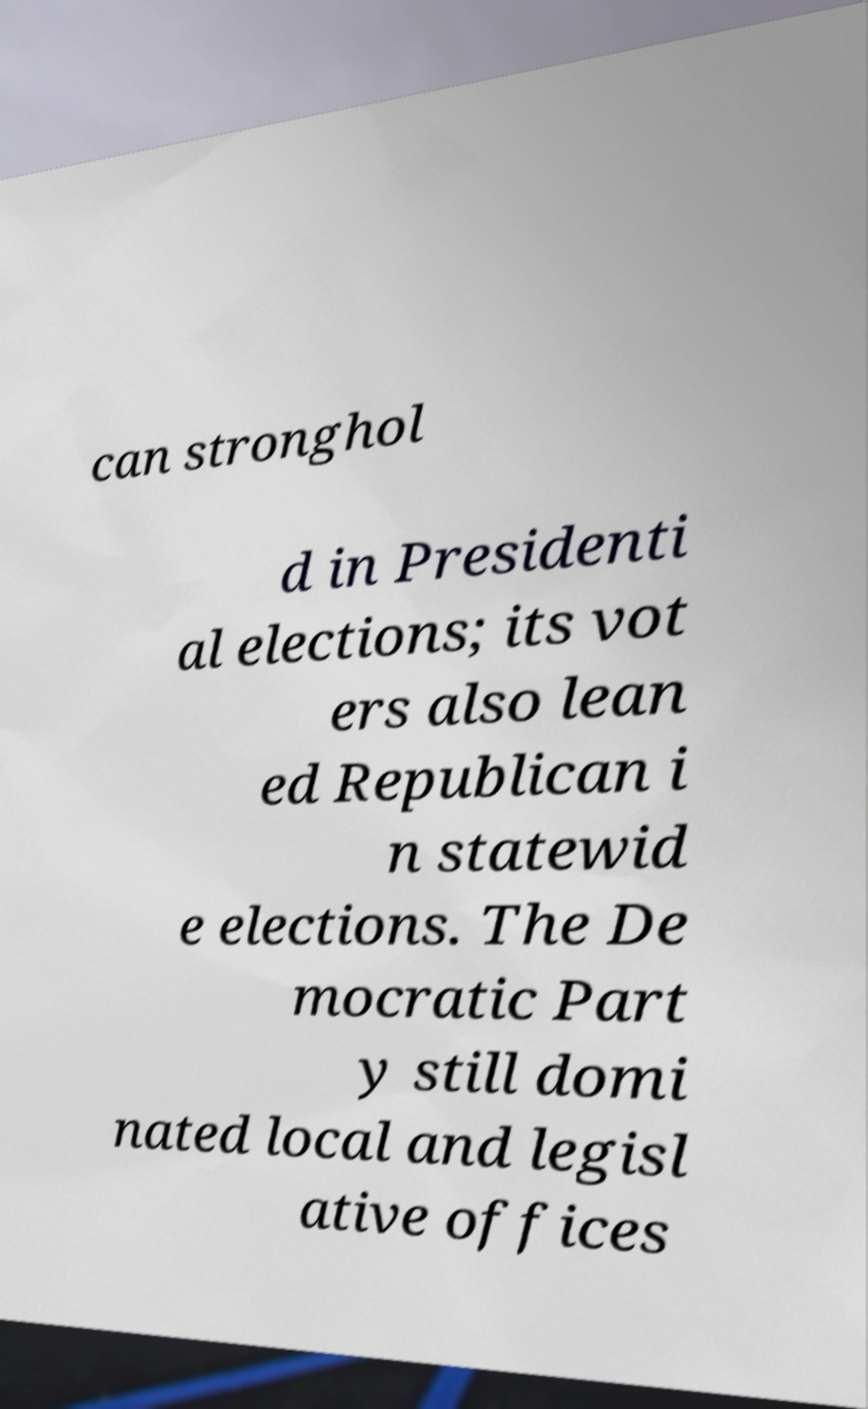Can you read and provide the text displayed in the image?This photo seems to have some interesting text. Can you extract and type it out for me? can stronghol d in Presidenti al elections; its vot ers also lean ed Republican i n statewid e elections. The De mocratic Part y still domi nated local and legisl ative offices 